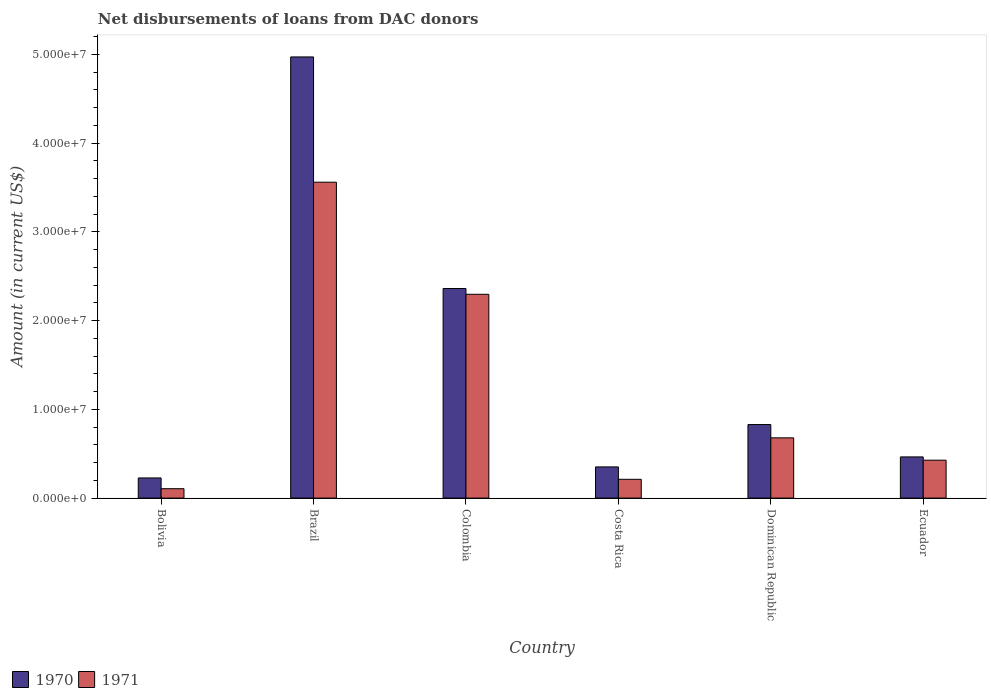How many different coloured bars are there?
Ensure brevity in your answer.  2. Are the number of bars per tick equal to the number of legend labels?
Your answer should be very brief. Yes. Are the number of bars on each tick of the X-axis equal?
Your response must be concise. Yes. How many bars are there on the 1st tick from the left?
Offer a very short reply. 2. How many bars are there on the 1st tick from the right?
Offer a very short reply. 2. In how many cases, is the number of bars for a given country not equal to the number of legend labels?
Ensure brevity in your answer.  0. What is the amount of loans disbursed in 1970 in Brazil?
Ensure brevity in your answer.  4.97e+07. Across all countries, what is the maximum amount of loans disbursed in 1970?
Offer a terse response. 4.97e+07. Across all countries, what is the minimum amount of loans disbursed in 1970?
Ensure brevity in your answer.  2.27e+06. In which country was the amount of loans disbursed in 1970 maximum?
Your answer should be very brief. Brazil. What is the total amount of loans disbursed in 1971 in the graph?
Make the answer very short. 7.28e+07. What is the difference between the amount of loans disbursed in 1971 in Colombia and that in Dominican Republic?
Offer a very short reply. 1.62e+07. What is the difference between the amount of loans disbursed in 1970 in Brazil and the amount of loans disbursed in 1971 in Colombia?
Make the answer very short. 2.67e+07. What is the average amount of loans disbursed in 1970 per country?
Provide a succinct answer. 1.53e+07. What is the difference between the amount of loans disbursed of/in 1970 and amount of loans disbursed of/in 1971 in Dominican Republic?
Make the answer very short. 1.50e+06. What is the ratio of the amount of loans disbursed in 1970 in Brazil to that in Ecuador?
Ensure brevity in your answer.  10.72. Is the amount of loans disbursed in 1971 in Dominican Republic less than that in Ecuador?
Your answer should be very brief. No. What is the difference between the highest and the second highest amount of loans disbursed in 1971?
Give a very brief answer. 1.26e+07. What is the difference between the highest and the lowest amount of loans disbursed in 1971?
Keep it short and to the point. 3.45e+07. Is the sum of the amount of loans disbursed in 1971 in Brazil and Dominican Republic greater than the maximum amount of loans disbursed in 1970 across all countries?
Offer a terse response. No. Are all the bars in the graph horizontal?
Keep it short and to the point. No. How many countries are there in the graph?
Ensure brevity in your answer.  6. What is the difference between two consecutive major ticks on the Y-axis?
Offer a terse response. 1.00e+07. Where does the legend appear in the graph?
Offer a very short reply. Bottom left. How many legend labels are there?
Keep it short and to the point. 2. What is the title of the graph?
Offer a very short reply. Net disbursements of loans from DAC donors. What is the label or title of the X-axis?
Ensure brevity in your answer.  Country. What is the label or title of the Y-axis?
Make the answer very short. Amount (in current US$). What is the Amount (in current US$) of 1970 in Bolivia?
Provide a succinct answer. 2.27e+06. What is the Amount (in current US$) in 1971 in Bolivia?
Provide a short and direct response. 1.06e+06. What is the Amount (in current US$) of 1970 in Brazil?
Ensure brevity in your answer.  4.97e+07. What is the Amount (in current US$) of 1971 in Brazil?
Your response must be concise. 3.56e+07. What is the Amount (in current US$) of 1970 in Colombia?
Your answer should be compact. 2.36e+07. What is the Amount (in current US$) of 1971 in Colombia?
Provide a short and direct response. 2.30e+07. What is the Amount (in current US$) in 1970 in Costa Rica?
Your response must be concise. 3.51e+06. What is the Amount (in current US$) of 1971 in Costa Rica?
Your answer should be compact. 2.12e+06. What is the Amount (in current US$) in 1970 in Dominican Republic?
Ensure brevity in your answer.  8.29e+06. What is the Amount (in current US$) of 1971 in Dominican Republic?
Make the answer very short. 6.79e+06. What is the Amount (in current US$) in 1970 in Ecuador?
Provide a short and direct response. 4.64e+06. What is the Amount (in current US$) in 1971 in Ecuador?
Give a very brief answer. 4.27e+06. Across all countries, what is the maximum Amount (in current US$) in 1970?
Ensure brevity in your answer.  4.97e+07. Across all countries, what is the maximum Amount (in current US$) of 1971?
Keep it short and to the point. 3.56e+07. Across all countries, what is the minimum Amount (in current US$) of 1970?
Your answer should be very brief. 2.27e+06. Across all countries, what is the minimum Amount (in current US$) in 1971?
Provide a short and direct response. 1.06e+06. What is the total Amount (in current US$) in 1970 in the graph?
Your answer should be compact. 9.20e+07. What is the total Amount (in current US$) of 1971 in the graph?
Provide a short and direct response. 7.28e+07. What is the difference between the Amount (in current US$) in 1970 in Bolivia and that in Brazil?
Give a very brief answer. -4.74e+07. What is the difference between the Amount (in current US$) in 1971 in Bolivia and that in Brazil?
Provide a succinct answer. -3.45e+07. What is the difference between the Amount (in current US$) of 1970 in Bolivia and that in Colombia?
Offer a terse response. -2.13e+07. What is the difference between the Amount (in current US$) of 1971 in Bolivia and that in Colombia?
Your answer should be compact. -2.19e+07. What is the difference between the Amount (in current US$) in 1970 in Bolivia and that in Costa Rica?
Provide a short and direct response. -1.24e+06. What is the difference between the Amount (in current US$) of 1971 in Bolivia and that in Costa Rica?
Your response must be concise. -1.06e+06. What is the difference between the Amount (in current US$) in 1970 in Bolivia and that in Dominican Republic?
Your answer should be compact. -6.02e+06. What is the difference between the Amount (in current US$) in 1971 in Bolivia and that in Dominican Republic?
Offer a terse response. -5.73e+06. What is the difference between the Amount (in current US$) of 1970 in Bolivia and that in Ecuador?
Your response must be concise. -2.37e+06. What is the difference between the Amount (in current US$) of 1971 in Bolivia and that in Ecuador?
Keep it short and to the point. -3.21e+06. What is the difference between the Amount (in current US$) in 1970 in Brazil and that in Colombia?
Ensure brevity in your answer.  2.61e+07. What is the difference between the Amount (in current US$) in 1971 in Brazil and that in Colombia?
Your answer should be very brief. 1.26e+07. What is the difference between the Amount (in current US$) in 1970 in Brazil and that in Costa Rica?
Offer a terse response. 4.62e+07. What is the difference between the Amount (in current US$) in 1971 in Brazil and that in Costa Rica?
Offer a very short reply. 3.35e+07. What is the difference between the Amount (in current US$) of 1970 in Brazil and that in Dominican Republic?
Your response must be concise. 4.14e+07. What is the difference between the Amount (in current US$) of 1971 in Brazil and that in Dominican Republic?
Your answer should be very brief. 2.88e+07. What is the difference between the Amount (in current US$) in 1970 in Brazil and that in Ecuador?
Ensure brevity in your answer.  4.51e+07. What is the difference between the Amount (in current US$) in 1971 in Brazil and that in Ecuador?
Your answer should be very brief. 3.13e+07. What is the difference between the Amount (in current US$) in 1970 in Colombia and that in Costa Rica?
Your answer should be compact. 2.01e+07. What is the difference between the Amount (in current US$) of 1971 in Colombia and that in Costa Rica?
Offer a terse response. 2.08e+07. What is the difference between the Amount (in current US$) of 1970 in Colombia and that in Dominican Republic?
Offer a terse response. 1.53e+07. What is the difference between the Amount (in current US$) in 1971 in Colombia and that in Dominican Republic?
Your answer should be compact. 1.62e+07. What is the difference between the Amount (in current US$) in 1970 in Colombia and that in Ecuador?
Provide a succinct answer. 1.90e+07. What is the difference between the Amount (in current US$) of 1971 in Colombia and that in Ecuador?
Offer a terse response. 1.87e+07. What is the difference between the Amount (in current US$) of 1970 in Costa Rica and that in Dominican Republic?
Offer a terse response. -4.77e+06. What is the difference between the Amount (in current US$) in 1971 in Costa Rica and that in Dominican Republic?
Provide a short and direct response. -4.67e+06. What is the difference between the Amount (in current US$) of 1970 in Costa Rica and that in Ecuador?
Your response must be concise. -1.13e+06. What is the difference between the Amount (in current US$) in 1971 in Costa Rica and that in Ecuador?
Keep it short and to the point. -2.16e+06. What is the difference between the Amount (in current US$) in 1970 in Dominican Republic and that in Ecuador?
Offer a terse response. 3.65e+06. What is the difference between the Amount (in current US$) of 1971 in Dominican Republic and that in Ecuador?
Make the answer very short. 2.52e+06. What is the difference between the Amount (in current US$) in 1970 in Bolivia and the Amount (in current US$) in 1971 in Brazil?
Your response must be concise. -3.33e+07. What is the difference between the Amount (in current US$) of 1970 in Bolivia and the Amount (in current US$) of 1971 in Colombia?
Ensure brevity in your answer.  -2.07e+07. What is the difference between the Amount (in current US$) of 1970 in Bolivia and the Amount (in current US$) of 1971 in Costa Rica?
Ensure brevity in your answer.  1.54e+05. What is the difference between the Amount (in current US$) of 1970 in Bolivia and the Amount (in current US$) of 1971 in Dominican Republic?
Keep it short and to the point. -4.52e+06. What is the difference between the Amount (in current US$) of 1970 in Bolivia and the Amount (in current US$) of 1971 in Ecuador?
Your answer should be compact. -2.00e+06. What is the difference between the Amount (in current US$) of 1970 in Brazil and the Amount (in current US$) of 1971 in Colombia?
Your answer should be very brief. 2.67e+07. What is the difference between the Amount (in current US$) of 1970 in Brazil and the Amount (in current US$) of 1971 in Costa Rica?
Your answer should be very brief. 4.76e+07. What is the difference between the Amount (in current US$) in 1970 in Brazil and the Amount (in current US$) in 1971 in Dominican Republic?
Make the answer very short. 4.29e+07. What is the difference between the Amount (in current US$) of 1970 in Brazil and the Amount (in current US$) of 1971 in Ecuador?
Provide a succinct answer. 4.54e+07. What is the difference between the Amount (in current US$) in 1970 in Colombia and the Amount (in current US$) in 1971 in Costa Rica?
Give a very brief answer. 2.15e+07. What is the difference between the Amount (in current US$) of 1970 in Colombia and the Amount (in current US$) of 1971 in Dominican Republic?
Your answer should be compact. 1.68e+07. What is the difference between the Amount (in current US$) of 1970 in Colombia and the Amount (in current US$) of 1971 in Ecuador?
Ensure brevity in your answer.  1.93e+07. What is the difference between the Amount (in current US$) of 1970 in Costa Rica and the Amount (in current US$) of 1971 in Dominican Republic?
Offer a very short reply. -3.28e+06. What is the difference between the Amount (in current US$) in 1970 in Costa Rica and the Amount (in current US$) in 1971 in Ecuador?
Provide a succinct answer. -7.58e+05. What is the difference between the Amount (in current US$) in 1970 in Dominican Republic and the Amount (in current US$) in 1971 in Ecuador?
Your answer should be very brief. 4.02e+06. What is the average Amount (in current US$) of 1970 per country?
Make the answer very short. 1.53e+07. What is the average Amount (in current US$) in 1971 per country?
Keep it short and to the point. 1.21e+07. What is the difference between the Amount (in current US$) in 1970 and Amount (in current US$) in 1971 in Bolivia?
Keep it short and to the point. 1.21e+06. What is the difference between the Amount (in current US$) in 1970 and Amount (in current US$) in 1971 in Brazil?
Your answer should be very brief. 1.41e+07. What is the difference between the Amount (in current US$) of 1970 and Amount (in current US$) of 1971 in Colombia?
Your answer should be very brief. 6.52e+05. What is the difference between the Amount (in current US$) in 1970 and Amount (in current US$) in 1971 in Costa Rica?
Ensure brevity in your answer.  1.40e+06. What is the difference between the Amount (in current US$) of 1970 and Amount (in current US$) of 1971 in Dominican Republic?
Ensure brevity in your answer.  1.50e+06. What is the difference between the Amount (in current US$) of 1970 and Amount (in current US$) of 1971 in Ecuador?
Offer a very short reply. 3.68e+05. What is the ratio of the Amount (in current US$) in 1970 in Bolivia to that in Brazil?
Keep it short and to the point. 0.05. What is the ratio of the Amount (in current US$) in 1971 in Bolivia to that in Brazil?
Your answer should be very brief. 0.03. What is the ratio of the Amount (in current US$) in 1970 in Bolivia to that in Colombia?
Give a very brief answer. 0.1. What is the ratio of the Amount (in current US$) of 1971 in Bolivia to that in Colombia?
Give a very brief answer. 0.05. What is the ratio of the Amount (in current US$) of 1970 in Bolivia to that in Costa Rica?
Make the answer very short. 0.65. What is the ratio of the Amount (in current US$) in 1970 in Bolivia to that in Dominican Republic?
Offer a terse response. 0.27. What is the ratio of the Amount (in current US$) in 1971 in Bolivia to that in Dominican Republic?
Your answer should be very brief. 0.16. What is the ratio of the Amount (in current US$) in 1970 in Bolivia to that in Ecuador?
Provide a short and direct response. 0.49. What is the ratio of the Amount (in current US$) in 1971 in Bolivia to that in Ecuador?
Provide a short and direct response. 0.25. What is the ratio of the Amount (in current US$) of 1970 in Brazil to that in Colombia?
Provide a short and direct response. 2.1. What is the ratio of the Amount (in current US$) of 1971 in Brazil to that in Colombia?
Provide a short and direct response. 1.55. What is the ratio of the Amount (in current US$) in 1970 in Brazil to that in Costa Rica?
Ensure brevity in your answer.  14.15. What is the ratio of the Amount (in current US$) in 1971 in Brazil to that in Costa Rica?
Provide a succinct answer. 16.82. What is the ratio of the Amount (in current US$) in 1970 in Brazil to that in Dominican Republic?
Give a very brief answer. 6. What is the ratio of the Amount (in current US$) in 1971 in Brazil to that in Dominican Republic?
Offer a terse response. 5.24. What is the ratio of the Amount (in current US$) in 1970 in Brazil to that in Ecuador?
Your answer should be very brief. 10.72. What is the ratio of the Amount (in current US$) in 1971 in Brazil to that in Ecuador?
Your response must be concise. 8.33. What is the ratio of the Amount (in current US$) in 1970 in Colombia to that in Costa Rica?
Make the answer very short. 6.72. What is the ratio of the Amount (in current US$) in 1971 in Colombia to that in Costa Rica?
Offer a terse response. 10.85. What is the ratio of the Amount (in current US$) in 1970 in Colombia to that in Dominican Republic?
Offer a terse response. 2.85. What is the ratio of the Amount (in current US$) of 1971 in Colombia to that in Dominican Republic?
Ensure brevity in your answer.  3.38. What is the ratio of the Amount (in current US$) in 1970 in Colombia to that in Ecuador?
Offer a terse response. 5.09. What is the ratio of the Amount (in current US$) of 1971 in Colombia to that in Ecuador?
Provide a succinct answer. 5.38. What is the ratio of the Amount (in current US$) of 1970 in Costa Rica to that in Dominican Republic?
Your response must be concise. 0.42. What is the ratio of the Amount (in current US$) in 1971 in Costa Rica to that in Dominican Republic?
Your response must be concise. 0.31. What is the ratio of the Amount (in current US$) in 1970 in Costa Rica to that in Ecuador?
Provide a short and direct response. 0.76. What is the ratio of the Amount (in current US$) of 1971 in Costa Rica to that in Ecuador?
Give a very brief answer. 0.5. What is the ratio of the Amount (in current US$) of 1970 in Dominican Republic to that in Ecuador?
Ensure brevity in your answer.  1.79. What is the ratio of the Amount (in current US$) of 1971 in Dominican Republic to that in Ecuador?
Ensure brevity in your answer.  1.59. What is the difference between the highest and the second highest Amount (in current US$) of 1970?
Your answer should be compact. 2.61e+07. What is the difference between the highest and the second highest Amount (in current US$) in 1971?
Make the answer very short. 1.26e+07. What is the difference between the highest and the lowest Amount (in current US$) of 1970?
Give a very brief answer. 4.74e+07. What is the difference between the highest and the lowest Amount (in current US$) of 1971?
Offer a very short reply. 3.45e+07. 